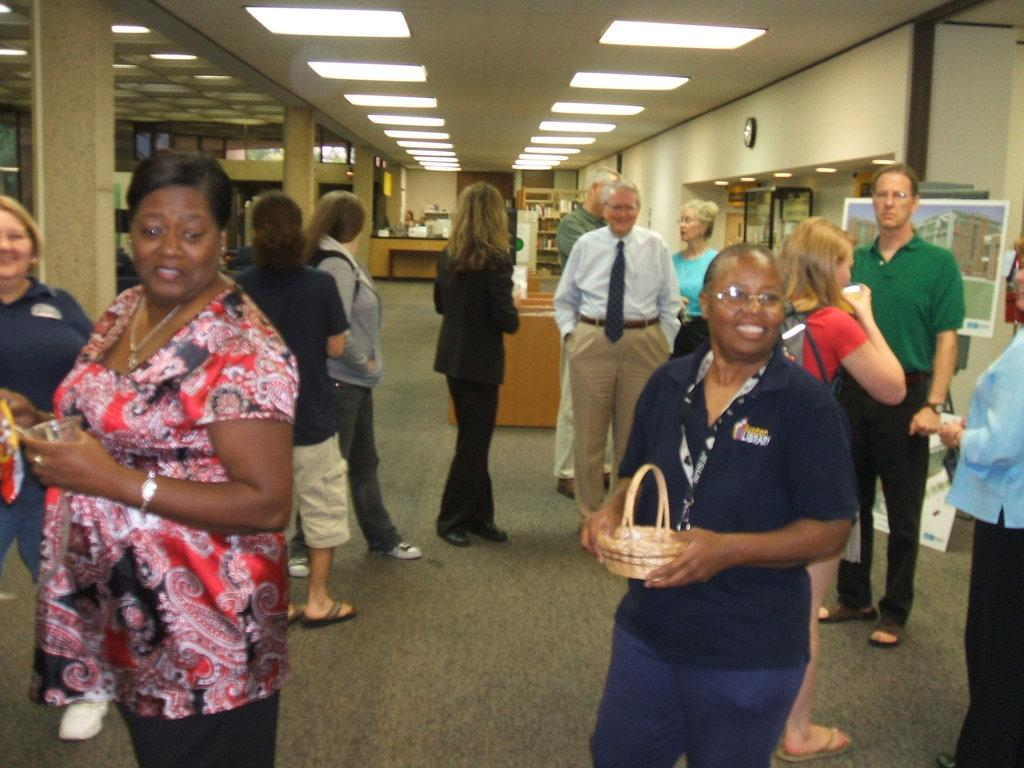What can be seen on the right side of the image? There are people on the right side of the image. What can be seen on the left side of the image? There are people on the left side of the image. What is located at the top side of the image? There are lights at the top side of the image. What type of location does the image appear to depict? The setting appears to be an office place. What type of feast is being prepared in the image? There is no feast or preparation for a feast visible in the image. What is your opinion on the distance between the people on the left and right sides of the image? The provided facts do not include any information about the distance between the people, so it is not possible to provide an opinion on it. 